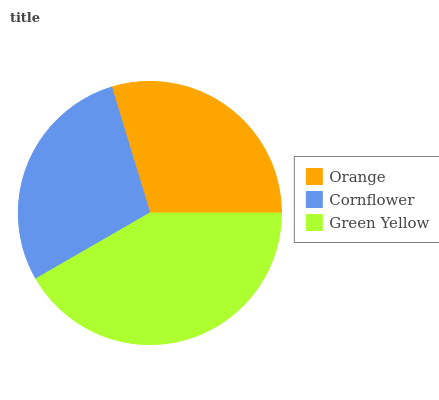Is Cornflower the minimum?
Answer yes or no. Yes. Is Green Yellow the maximum?
Answer yes or no. Yes. Is Green Yellow the minimum?
Answer yes or no. No. Is Cornflower the maximum?
Answer yes or no. No. Is Green Yellow greater than Cornflower?
Answer yes or no. Yes. Is Cornflower less than Green Yellow?
Answer yes or no. Yes. Is Cornflower greater than Green Yellow?
Answer yes or no. No. Is Green Yellow less than Cornflower?
Answer yes or no. No. Is Orange the high median?
Answer yes or no. Yes. Is Orange the low median?
Answer yes or no. Yes. Is Green Yellow the high median?
Answer yes or no. No. Is Cornflower the low median?
Answer yes or no. No. 